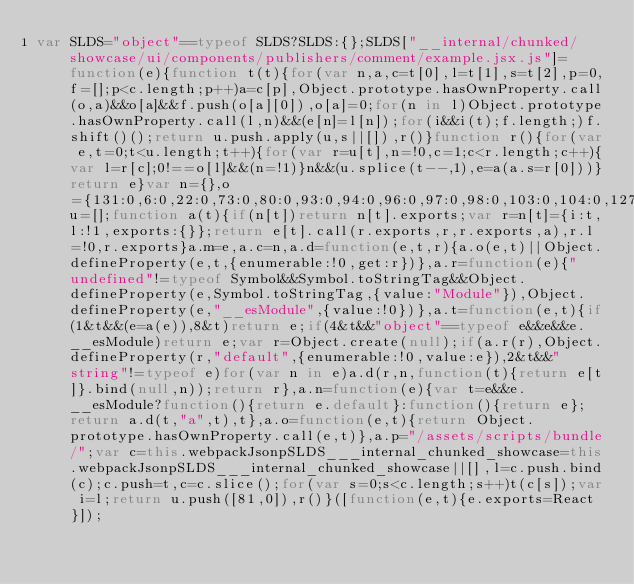Convert code to text. <code><loc_0><loc_0><loc_500><loc_500><_JavaScript_>var SLDS="object"==typeof SLDS?SLDS:{};SLDS["__internal/chunked/showcase/ui/components/publishers/comment/example.jsx.js"]=function(e){function t(t){for(var n,a,c=t[0],l=t[1],s=t[2],p=0,f=[];p<c.length;p++)a=c[p],Object.prototype.hasOwnProperty.call(o,a)&&o[a]&&f.push(o[a][0]),o[a]=0;for(n in l)Object.prototype.hasOwnProperty.call(l,n)&&(e[n]=l[n]);for(i&&i(t);f.length;)f.shift()();return u.push.apply(u,s||[]),r()}function r(){for(var e,t=0;t<u.length;t++){for(var r=u[t],n=!0,c=1;c<r.length;c++){var l=r[c];0!==o[l]&&(n=!1)}n&&(u.splice(t--,1),e=a(a.s=r[0]))}return e}var n={},o={131:0,6:0,22:0,73:0,80:0,93:0,94:0,96:0,97:0,98:0,103:0,104:0,127:0,135:0,140:0,142:0},u=[];function a(t){if(n[t])return n[t].exports;var r=n[t]={i:t,l:!1,exports:{}};return e[t].call(r.exports,r,r.exports,a),r.l=!0,r.exports}a.m=e,a.c=n,a.d=function(e,t,r){a.o(e,t)||Object.defineProperty(e,t,{enumerable:!0,get:r})},a.r=function(e){"undefined"!=typeof Symbol&&Symbol.toStringTag&&Object.defineProperty(e,Symbol.toStringTag,{value:"Module"}),Object.defineProperty(e,"__esModule",{value:!0})},a.t=function(e,t){if(1&t&&(e=a(e)),8&t)return e;if(4&t&&"object"==typeof e&&e&&e.__esModule)return e;var r=Object.create(null);if(a.r(r),Object.defineProperty(r,"default",{enumerable:!0,value:e}),2&t&&"string"!=typeof e)for(var n in e)a.d(r,n,function(t){return e[t]}.bind(null,n));return r},a.n=function(e){var t=e&&e.__esModule?function(){return e.default}:function(){return e};return a.d(t,"a",t),t},a.o=function(e,t){return Object.prototype.hasOwnProperty.call(e,t)},a.p="/assets/scripts/bundle/";var c=this.webpackJsonpSLDS___internal_chunked_showcase=this.webpackJsonpSLDS___internal_chunked_showcase||[],l=c.push.bind(c);c.push=t,c=c.slice();for(var s=0;s<c.length;s++)t(c[s]);var i=l;return u.push([81,0]),r()}([function(e,t){e.exports=React}]);</code> 